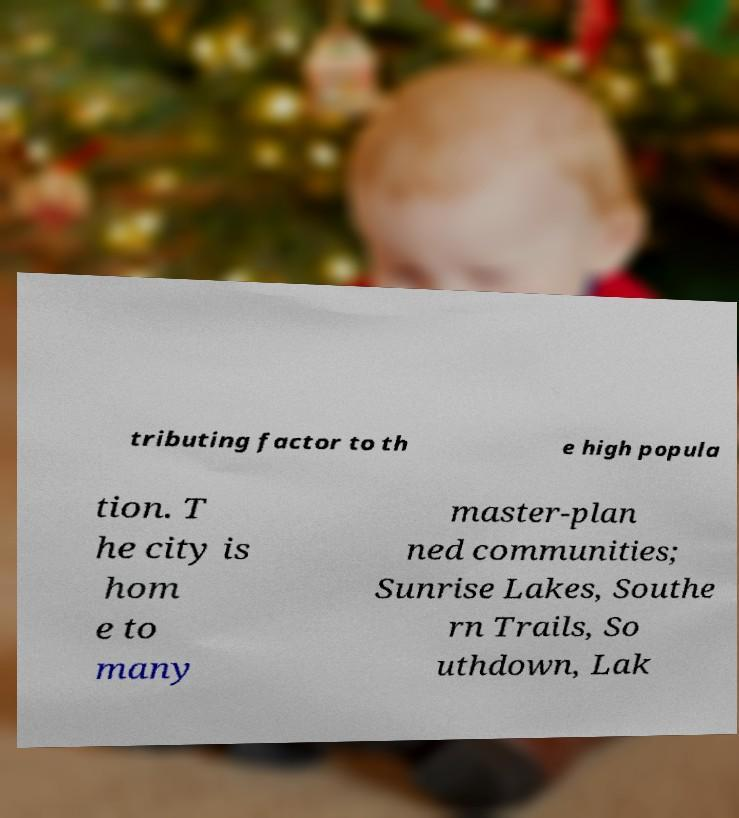Could you assist in decoding the text presented in this image and type it out clearly? tributing factor to th e high popula tion. T he city is hom e to many master-plan ned communities; Sunrise Lakes, Southe rn Trails, So uthdown, Lak 